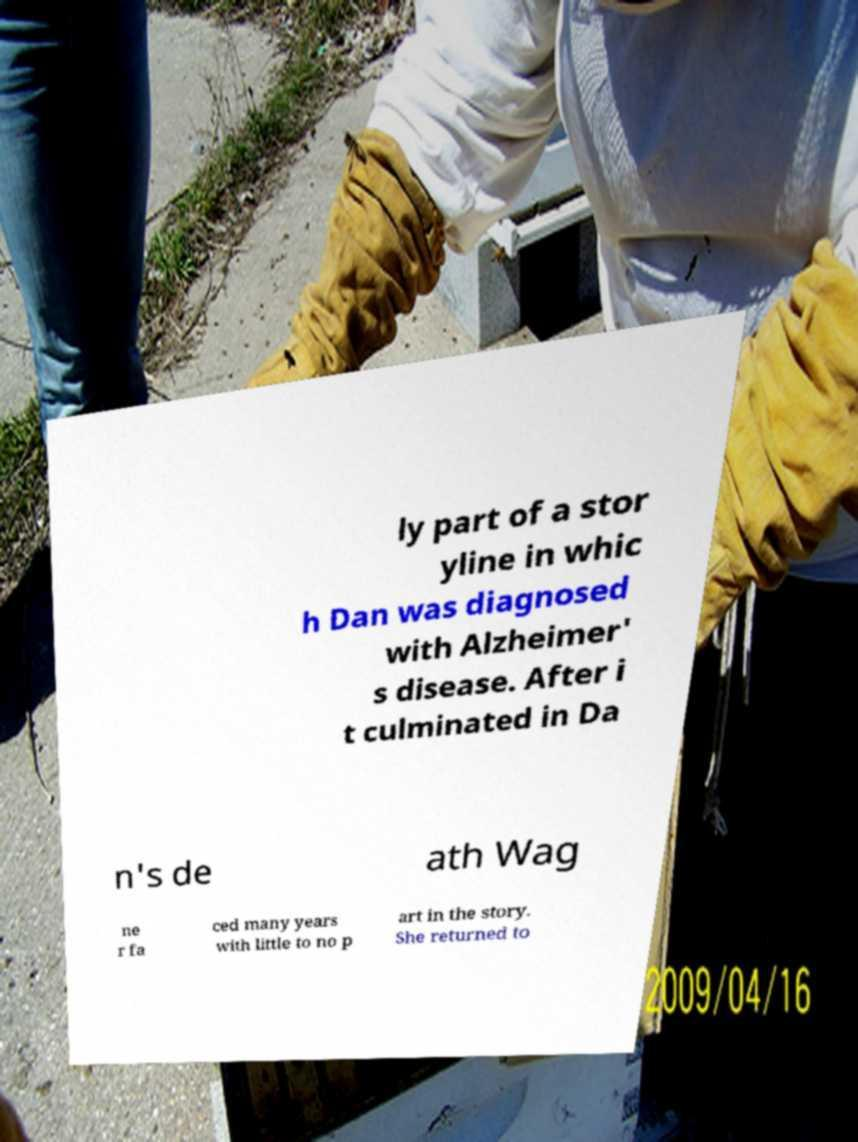There's text embedded in this image that I need extracted. Can you transcribe it verbatim? ly part of a stor yline in whic h Dan was diagnosed with Alzheimer' s disease. After i t culminated in Da n's de ath Wag ne r fa ced many years with little to no p art in the story. She returned to 